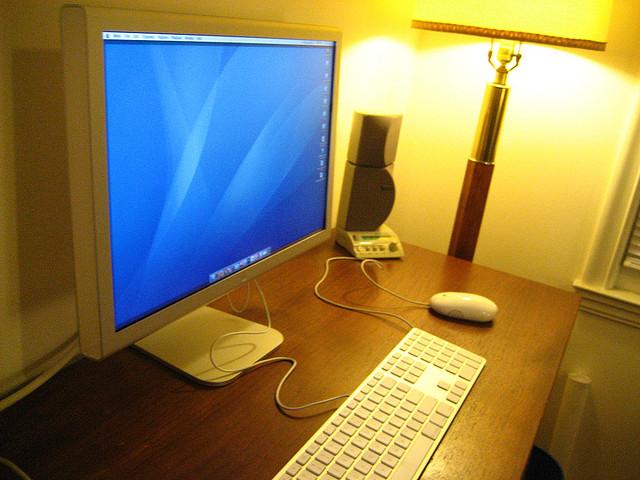Is there a mouse in view?
Be succinct. Yes. Is this junky desk?
Keep it brief. No. Is the lamp turned on?
Short answer required. Yes. 